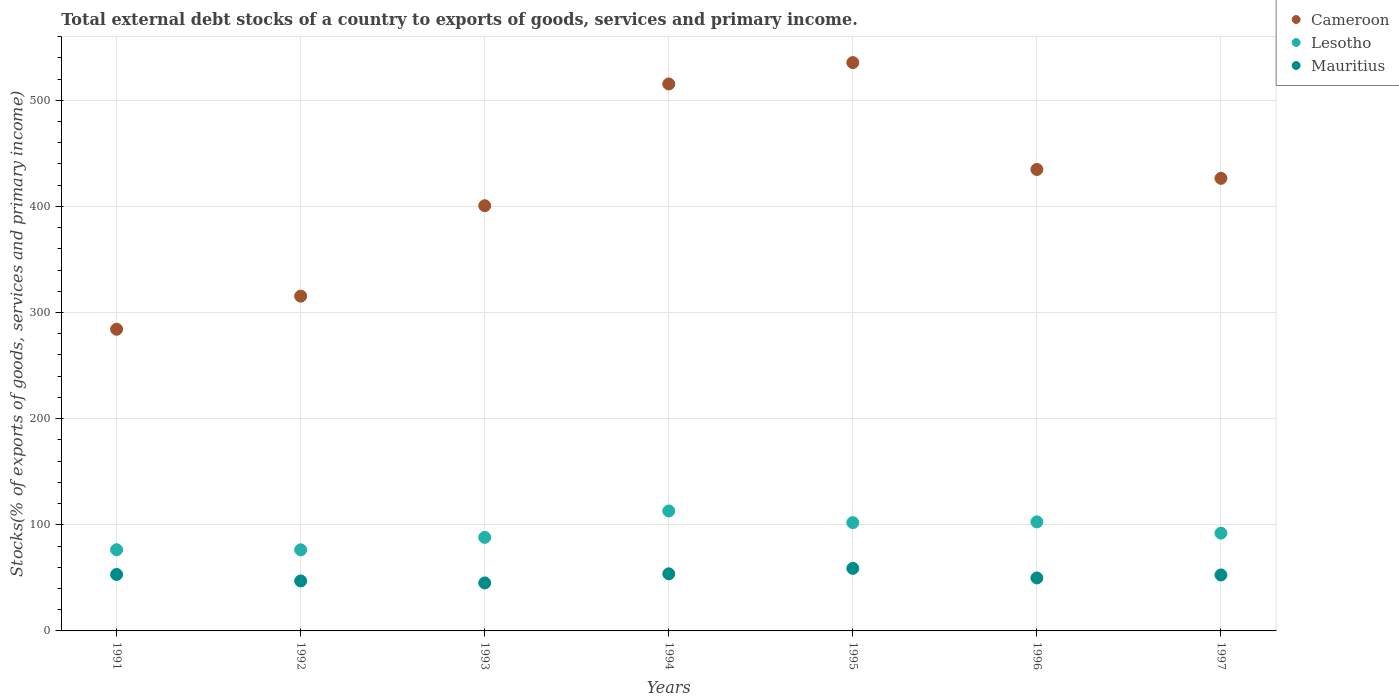How many different coloured dotlines are there?
Your answer should be very brief. 3. What is the total debt stocks in Lesotho in 1997?
Ensure brevity in your answer.  92.13. Across all years, what is the maximum total debt stocks in Cameroon?
Ensure brevity in your answer.  535.53. Across all years, what is the minimum total debt stocks in Lesotho?
Keep it short and to the point. 76.44. What is the total total debt stocks in Cameroon in the graph?
Your answer should be very brief. 2912.61. What is the difference between the total debt stocks in Lesotho in 1992 and that in 1995?
Offer a terse response. -25.62. What is the difference between the total debt stocks in Mauritius in 1991 and the total debt stocks in Lesotho in 1992?
Your answer should be compact. -23.24. What is the average total debt stocks in Cameroon per year?
Your response must be concise. 416.09. In the year 1992, what is the difference between the total debt stocks in Lesotho and total debt stocks in Mauritius?
Your answer should be very brief. 29.33. What is the ratio of the total debt stocks in Mauritius in 1991 to that in 1995?
Give a very brief answer. 0.9. What is the difference between the highest and the second highest total debt stocks in Lesotho?
Your answer should be compact. 10.27. What is the difference between the highest and the lowest total debt stocks in Cameroon?
Give a very brief answer. 251.26. In how many years, is the total debt stocks in Cameroon greater than the average total debt stocks in Cameroon taken over all years?
Keep it short and to the point. 4. Is the sum of the total debt stocks in Lesotho in 1992 and 1997 greater than the maximum total debt stocks in Mauritius across all years?
Keep it short and to the point. Yes. Is the total debt stocks in Cameroon strictly greater than the total debt stocks in Lesotho over the years?
Ensure brevity in your answer.  Yes. How many years are there in the graph?
Make the answer very short. 7. Does the graph contain any zero values?
Offer a terse response. No. Where does the legend appear in the graph?
Your answer should be compact. Top right. How many legend labels are there?
Your response must be concise. 3. What is the title of the graph?
Provide a short and direct response. Total external debt stocks of a country to exports of goods, services and primary income. Does "Montenegro" appear as one of the legend labels in the graph?
Provide a short and direct response. No. What is the label or title of the Y-axis?
Provide a short and direct response. Stocks(% of exports of goods, services and primary income). What is the Stocks(% of exports of goods, services and primary income) of Cameroon in 1991?
Your response must be concise. 284.26. What is the Stocks(% of exports of goods, services and primary income) of Lesotho in 1991?
Your response must be concise. 76.5. What is the Stocks(% of exports of goods, services and primary income) in Mauritius in 1991?
Provide a succinct answer. 53.2. What is the Stocks(% of exports of goods, services and primary income) of Cameroon in 1992?
Offer a very short reply. 315.47. What is the Stocks(% of exports of goods, services and primary income) in Lesotho in 1992?
Offer a terse response. 76.44. What is the Stocks(% of exports of goods, services and primary income) in Mauritius in 1992?
Offer a terse response. 47.11. What is the Stocks(% of exports of goods, services and primary income) of Cameroon in 1993?
Provide a succinct answer. 400.67. What is the Stocks(% of exports of goods, services and primary income) of Lesotho in 1993?
Your answer should be compact. 88.13. What is the Stocks(% of exports of goods, services and primary income) in Mauritius in 1993?
Offer a terse response. 45.22. What is the Stocks(% of exports of goods, services and primary income) of Cameroon in 1994?
Provide a succinct answer. 515.38. What is the Stocks(% of exports of goods, services and primary income) in Lesotho in 1994?
Offer a very short reply. 113.02. What is the Stocks(% of exports of goods, services and primary income) of Mauritius in 1994?
Your answer should be very brief. 53.81. What is the Stocks(% of exports of goods, services and primary income) in Cameroon in 1995?
Provide a short and direct response. 535.53. What is the Stocks(% of exports of goods, services and primary income) in Lesotho in 1995?
Your response must be concise. 102.05. What is the Stocks(% of exports of goods, services and primary income) of Mauritius in 1995?
Your answer should be very brief. 58.92. What is the Stocks(% of exports of goods, services and primary income) of Cameroon in 1996?
Keep it short and to the point. 434.84. What is the Stocks(% of exports of goods, services and primary income) of Lesotho in 1996?
Your answer should be compact. 102.75. What is the Stocks(% of exports of goods, services and primary income) of Mauritius in 1996?
Keep it short and to the point. 49.92. What is the Stocks(% of exports of goods, services and primary income) in Cameroon in 1997?
Provide a succinct answer. 426.46. What is the Stocks(% of exports of goods, services and primary income) in Lesotho in 1997?
Your answer should be very brief. 92.13. What is the Stocks(% of exports of goods, services and primary income) of Mauritius in 1997?
Offer a terse response. 52.73. Across all years, what is the maximum Stocks(% of exports of goods, services and primary income) in Cameroon?
Provide a short and direct response. 535.53. Across all years, what is the maximum Stocks(% of exports of goods, services and primary income) of Lesotho?
Your response must be concise. 113.02. Across all years, what is the maximum Stocks(% of exports of goods, services and primary income) of Mauritius?
Keep it short and to the point. 58.92. Across all years, what is the minimum Stocks(% of exports of goods, services and primary income) in Cameroon?
Your answer should be compact. 284.26. Across all years, what is the minimum Stocks(% of exports of goods, services and primary income) of Lesotho?
Give a very brief answer. 76.44. Across all years, what is the minimum Stocks(% of exports of goods, services and primary income) of Mauritius?
Ensure brevity in your answer.  45.22. What is the total Stocks(% of exports of goods, services and primary income) in Cameroon in the graph?
Offer a terse response. 2912.61. What is the total Stocks(% of exports of goods, services and primary income) in Lesotho in the graph?
Your answer should be very brief. 651.03. What is the total Stocks(% of exports of goods, services and primary income) of Mauritius in the graph?
Provide a short and direct response. 360.91. What is the difference between the Stocks(% of exports of goods, services and primary income) in Cameroon in 1991 and that in 1992?
Provide a short and direct response. -31.2. What is the difference between the Stocks(% of exports of goods, services and primary income) in Lesotho in 1991 and that in 1992?
Keep it short and to the point. 0.06. What is the difference between the Stocks(% of exports of goods, services and primary income) in Mauritius in 1991 and that in 1992?
Offer a terse response. 6.09. What is the difference between the Stocks(% of exports of goods, services and primary income) in Cameroon in 1991 and that in 1993?
Keep it short and to the point. -116.4. What is the difference between the Stocks(% of exports of goods, services and primary income) in Lesotho in 1991 and that in 1993?
Make the answer very short. -11.63. What is the difference between the Stocks(% of exports of goods, services and primary income) in Mauritius in 1991 and that in 1993?
Provide a succinct answer. 7.98. What is the difference between the Stocks(% of exports of goods, services and primary income) of Cameroon in 1991 and that in 1994?
Your response must be concise. -231.12. What is the difference between the Stocks(% of exports of goods, services and primary income) in Lesotho in 1991 and that in 1994?
Your answer should be very brief. -36.52. What is the difference between the Stocks(% of exports of goods, services and primary income) of Mauritius in 1991 and that in 1994?
Keep it short and to the point. -0.61. What is the difference between the Stocks(% of exports of goods, services and primary income) of Cameroon in 1991 and that in 1995?
Your answer should be compact. -251.26. What is the difference between the Stocks(% of exports of goods, services and primary income) in Lesotho in 1991 and that in 1995?
Keep it short and to the point. -25.55. What is the difference between the Stocks(% of exports of goods, services and primary income) in Mauritius in 1991 and that in 1995?
Give a very brief answer. -5.72. What is the difference between the Stocks(% of exports of goods, services and primary income) of Cameroon in 1991 and that in 1996?
Provide a short and direct response. -150.57. What is the difference between the Stocks(% of exports of goods, services and primary income) in Lesotho in 1991 and that in 1996?
Your response must be concise. -26.25. What is the difference between the Stocks(% of exports of goods, services and primary income) of Mauritius in 1991 and that in 1996?
Your answer should be compact. 3.28. What is the difference between the Stocks(% of exports of goods, services and primary income) of Cameroon in 1991 and that in 1997?
Provide a succinct answer. -142.2. What is the difference between the Stocks(% of exports of goods, services and primary income) in Lesotho in 1991 and that in 1997?
Provide a succinct answer. -15.63. What is the difference between the Stocks(% of exports of goods, services and primary income) of Mauritius in 1991 and that in 1997?
Make the answer very short. 0.47. What is the difference between the Stocks(% of exports of goods, services and primary income) of Cameroon in 1992 and that in 1993?
Your response must be concise. -85.2. What is the difference between the Stocks(% of exports of goods, services and primary income) in Lesotho in 1992 and that in 1993?
Provide a succinct answer. -11.69. What is the difference between the Stocks(% of exports of goods, services and primary income) of Mauritius in 1992 and that in 1993?
Your answer should be compact. 1.89. What is the difference between the Stocks(% of exports of goods, services and primary income) of Cameroon in 1992 and that in 1994?
Ensure brevity in your answer.  -199.91. What is the difference between the Stocks(% of exports of goods, services and primary income) of Lesotho in 1992 and that in 1994?
Provide a succinct answer. -36.59. What is the difference between the Stocks(% of exports of goods, services and primary income) of Mauritius in 1992 and that in 1994?
Your answer should be compact. -6.7. What is the difference between the Stocks(% of exports of goods, services and primary income) of Cameroon in 1992 and that in 1995?
Provide a succinct answer. -220.06. What is the difference between the Stocks(% of exports of goods, services and primary income) of Lesotho in 1992 and that in 1995?
Provide a succinct answer. -25.62. What is the difference between the Stocks(% of exports of goods, services and primary income) of Mauritius in 1992 and that in 1995?
Offer a terse response. -11.81. What is the difference between the Stocks(% of exports of goods, services and primary income) of Cameroon in 1992 and that in 1996?
Your response must be concise. -119.37. What is the difference between the Stocks(% of exports of goods, services and primary income) in Lesotho in 1992 and that in 1996?
Provide a short and direct response. -26.31. What is the difference between the Stocks(% of exports of goods, services and primary income) of Mauritius in 1992 and that in 1996?
Ensure brevity in your answer.  -2.81. What is the difference between the Stocks(% of exports of goods, services and primary income) in Cameroon in 1992 and that in 1997?
Offer a terse response. -111. What is the difference between the Stocks(% of exports of goods, services and primary income) in Lesotho in 1992 and that in 1997?
Offer a terse response. -15.7. What is the difference between the Stocks(% of exports of goods, services and primary income) of Mauritius in 1992 and that in 1997?
Provide a short and direct response. -5.62. What is the difference between the Stocks(% of exports of goods, services and primary income) in Cameroon in 1993 and that in 1994?
Keep it short and to the point. -114.71. What is the difference between the Stocks(% of exports of goods, services and primary income) in Lesotho in 1993 and that in 1994?
Give a very brief answer. -24.9. What is the difference between the Stocks(% of exports of goods, services and primary income) of Mauritius in 1993 and that in 1994?
Your response must be concise. -8.59. What is the difference between the Stocks(% of exports of goods, services and primary income) of Cameroon in 1993 and that in 1995?
Ensure brevity in your answer.  -134.86. What is the difference between the Stocks(% of exports of goods, services and primary income) of Lesotho in 1993 and that in 1995?
Your answer should be compact. -13.93. What is the difference between the Stocks(% of exports of goods, services and primary income) in Mauritius in 1993 and that in 1995?
Offer a very short reply. -13.7. What is the difference between the Stocks(% of exports of goods, services and primary income) in Cameroon in 1993 and that in 1996?
Your answer should be very brief. -34.17. What is the difference between the Stocks(% of exports of goods, services and primary income) in Lesotho in 1993 and that in 1996?
Ensure brevity in your answer.  -14.63. What is the difference between the Stocks(% of exports of goods, services and primary income) of Mauritius in 1993 and that in 1996?
Your answer should be compact. -4.7. What is the difference between the Stocks(% of exports of goods, services and primary income) of Cameroon in 1993 and that in 1997?
Give a very brief answer. -25.79. What is the difference between the Stocks(% of exports of goods, services and primary income) in Lesotho in 1993 and that in 1997?
Offer a terse response. -4.01. What is the difference between the Stocks(% of exports of goods, services and primary income) of Mauritius in 1993 and that in 1997?
Your answer should be compact. -7.51. What is the difference between the Stocks(% of exports of goods, services and primary income) of Cameroon in 1994 and that in 1995?
Ensure brevity in your answer.  -20.15. What is the difference between the Stocks(% of exports of goods, services and primary income) in Lesotho in 1994 and that in 1995?
Your response must be concise. 10.97. What is the difference between the Stocks(% of exports of goods, services and primary income) of Mauritius in 1994 and that in 1995?
Provide a short and direct response. -5.11. What is the difference between the Stocks(% of exports of goods, services and primary income) of Cameroon in 1994 and that in 1996?
Provide a succinct answer. 80.54. What is the difference between the Stocks(% of exports of goods, services and primary income) of Lesotho in 1994 and that in 1996?
Offer a very short reply. 10.27. What is the difference between the Stocks(% of exports of goods, services and primary income) of Mauritius in 1994 and that in 1996?
Make the answer very short. 3.89. What is the difference between the Stocks(% of exports of goods, services and primary income) of Cameroon in 1994 and that in 1997?
Offer a very short reply. 88.92. What is the difference between the Stocks(% of exports of goods, services and primary income) in Lesotho in 1994 and that in 1997?
Your response must be concise. 20.89. What is the difference between the Stocks(% of exports of goods, services and primary income) of Mauritius in 1994 and that in 1997?
Ensure brevity in your answer.  1.09. What is the difference between the Stocks(% of exports of goods, services and primary income) in Cameroon in 1995 and that in 1996?
Your answer should be compact. 100.69. What is the difference between the Stocks(% of exports of goods, services and primary income) of Lesotho in 1995 and that in 1996?
Make the answer very short. -0.7. What is the difference between the Stocks(% of exports of goods, services and primary income) in Mauritius in 1995 and that in 1996?
Your response must be concise. 9. What is the difference between the Stocks(% of exports of goods, services and primary income) of Cameroon in 1995 and that in 1997?
Offer a terse response. 109.06. What is the difference between the Stocks(% of exports of goods, services and primary income) in Lesotho in 1995 and that in 1997?
Give a very brief answer. 9.92. What is the difference between the Stocks(% of exports of goods, services and primary income) in Mauritius in 1995 and that in 1997?
Keep it short and to the point. 6.19. What is the difference between the Stocks(% of exports of goods, services and primary income) in Cameroon in 1996 and that in 1997?
Your response must be concise. 8.37. What is the difference between the Stocks(% of exports of goods, services and primary income) in Lesotho in 1996 and that in 1997?
Offer a terse response. 10.62. What is the difference between the Stocks(% of exports of goods, services and primary income) in Mauritius in 1996 and that in 1997?
Your answer should be compact. -2.81. What is the difference between the Stocks(% of exports of goods, services and primary income) of Cameroon in 1991 and the Stocks(% of exports of goods, services and primary income) of Lesotho in 1992?
Provide a short and direct response. 207.83. What is the difference between the Stocks(% of exports of goods, services and primary income) of Cameroon in 1991 and the Stocks(% of exports of goods, services and primary income) of Mauritius in 1992?
Your answer should be compact. 237.15. What is the difference between the Stocks(% of exports of goods, services and primary income) of Lesotho in 1991 and the Stocks(% of exports of goods, services and primary income) of Mauritius in 1992?
Provide a succinct answer. 29.39. What is the difference between the Stocks(% of exports of goods, services and primary income) of Cameroon in 1991 and the Stocks(% of exports of goods, services and primary income) of Lesotho in 1993?
Provide a succinct answer. 196.14. What is the difference between the Stocks(% of exports of goods, services and primary income) in Cameroon in 1991 and the Stocks(% of exports of goods, services and primary income) in Mauritius in 1993?
Your answer should be very brief. 239.04. What is the difference between the Stocks(% of exports of goods, services and primary income) of Lesotho in 1991 and the Stocks(% of exports of goods, services and primary income) of Mauritius in 1993?
Offer a terse response. 31.28. What is the difference between the Stocks(% of exports of goods, services and primary income) of Cameroon in 1991 and the Stocks(% of exports of goods, services and primary income) of Lesotho in 1994?
Offer a terse response. 171.24. What is the difference between the Stocks(% of exports of goods, services and primary income) in Cameroon in 1991 and the Stocks(% of exports of goods, services and primary income) in Mauritius in 1994?
Offer a very short reply. 230.45. What is the difference between the Stocks(% of exports of goods, services and primary income) of Lesotho in 1991 and the Stocks(% of exports of goods, services and primary income) of Mauritius in 1994?
Offer a terse response. 22.69. What is the difference between the Stocks(% of exports of goods, services and primary income) in Cameroon in 1991 and the Stocks(% of exports of goods, services and primary income) in Lesotho in 1995?
Offer a terse response. 182.21. What is the difference between the Stocks(% of exports of goods, services and primary income) in Cameroon in 1991 and the Stocks(% of exports of goods, services and primary income) in Mauritius in 1995?
Your answer should be very brief. 225.34. What is the difference between the Stocks(% of exports of goods, services and primary income) in Lesotho in 1991 and the Stocks(% of exports of goods, services and primary income) in Mauritius in 1995?
Give a very brief answer. 17.58. What is the difference between the Stocks(% of exports of goods, services and primary income) of Cameroon in 1991 and the Stocks(% of exports of goods, services and primary income) of Lesotho in 1996?
Your answer should be very brief. 181.51. What is the difference between the Stocks(% of exports of goods, services and primary income) in Cameroon in 1991 and the Stocks(% of exports of goods, services and primary income) in Mauritius in 1996?
Provide a succinct answer. 234.34. What is the difference between the Stocks(% of exports of goods, services and primary income) in Lesotho in 1991 and the Stocks(% of exports of goods, services and primary income) in Mauritius in 1996?
Your answer should be compact. 26.58. What is the difference between the Stocks(% of exports of goods, services and primary income) in Cameroon in 1991 and the Stocks(% of exports of goods, services and primary income) in Lesotho in 1997?
Ensure brevity in your answer.  192.13. What is the difference between the Stocks(% of exports of goods, services and primary income) in Cameroon in 1991 and the Stocks(% of exports of goods, services and primary income) in Mauritius in 1997?
Your answer should be very brief. 231.54. What is the difference between the Stocks(% of exports of goods, services and primary income) in Lesotho in 1991 and the Stocks(% of exports of goods, services and primary income) in Mauritius in 1997?
Offer a terse response. 23.77. What is the difference between the Stocks(% of exports of goods, services and primary income) in Cameroon in 1992 and the Stocks(% of exports of goods, services and primary income) in Lesotho in 1993?
Offer a terse response. 227.34. What is the difference between the Stocks(% of exports of goods, services and primary income) in Cameroon in 1992 and the Stocks(% of exports of goods, services and primary income) in Mauritius in 1993?
Your response must be concise. 270.25. What is the difference between the Stocks(% of exports of goods, services and primary income) of Lesotho in 1992 and the Stocks(% of exports of goods, services and primary income) of Mauritius in 1993?
Make the answer very short. 31.22. What is the difference between the Stocks(% of exports of goods, services and primary income) of Cameroon in 1992 and the Stocks(% of exports of goods, services and primary income) of Lesotho in 1994?
Make the answer very short. 202.44. What is the difference between the Stocks(% of exports of goods, services and primary income) in Cameroon in 1992 and the Stocks(% of exports of goods, services and primary income) in Mauritius in 1994?
Your answer should be compact. 261.65. What is the difference between the Stocks(% of exports of goods, services and primary income) in Lesotho in 1992 and the Stocks(% of exports of goods, services and primary income) in Mauritius in 1994?
Keep it short and to the point. 22.62. What is the difference between the Stocks(% of exports of goods, services and primary income) in Cameroon in 1992 and the Stocks(% of exports of goods, services and primary income) in Lesotho in 1995?
Ensure brevity in your answer.  213.41. What is the difference between the Stocks(% of exports of goods, services and primary income) of Cameroon in 1992 and the Stocks(% of exports of goods, services and primary income) of Mauritius in 1995?
Your answer should be very brief. 256.55. What is the difference between the Stocks(% of exports of goods, services and primary income) in Lesotho in 1992 and the Stocks(% of exports of goods, services and primary income) in Mauritius in 1995?
Your response must be concise. 17.52. What is the difference between the Stocks(% of exports of goods, services and primary income) in Cameroon in 1992 and the Stocks(% of exports of goods, services and primary income) in Lesotho in 1996?
Your response must be concise. 212.72. What is the difference between the Stocks(% of exports of goods, services and primary income) in Cameroon in 1992 and the Stocks(% of exports of goods, services and primary income) in Mauritius in 1996?
Provide a short and direct response. 265.55. What is the difference between the Stocks(% of exports of goods, services and primary income) of Lesotho in 1992 and the Stocks(% of exports of goods, services and primary income) of Mauritius in 1996?
Keep it short and to the point. 26.52. What is the difference between the Stocks(% of exports of goods, services and primary income) in Cameroon in 1992 and the Stocks(% of exports of goods, services and primary income) in Lesotho in 1997?
Offer a terse response. 223.33. What is the difference between the Stocks(% of exports of goods, services and primary income) in Cameroon in 1992 and the Stocks(% of exports of goods, services and primary income) in Mauritius in 1997?
Make the answer very short. 262.74. What is the difference between the Stocks(% of exports of goods, services and primary income) in Lesotho in 1992 and the Stocks(% of exports of goods, services and primary income) in Mauritius in 1997?
Your answer should be very brief. 23.71. What is the difference between the Stocks(% of exports of goods, services and primary income) of Cameroon in 1993 and the Stocks(% of exports of goods, services and primary income) of Lesotho in 1994?
Keep it short and to the point. 287.64. What is the difference between the Stocks(% of exports of goods, services and primary income) of Cameroon in 1993 and the Stocks(% of exports of goods, services and primary income) of Mauritius in 1994?
Your answer should be compact. 346.86. What is the difference between the Stocks(% of exports of goods, services and primary income) in Lesotho in 1993 and the Stocks(% of exports of goods, services and primary income) in Mauritius in 1994?
Your answer should be compact. 34.31. What is the difference between the Stocks(% of exports of goods, services and primary income) in Cameroon in 1993 and the Stocks(% of exports of goods, services and primary income) in Lesotho in 1995?
Your response must be concise. 298.62. What is the difference between the Stocks(% of exports of goods, services and primary income) of Cameroon in 1993 and the Stocks(% of exports of goods, services and primary income) of Mauritius in 1995?
Your response must be concise. 341.75. What is the difference between the Stocks(% of exports of goods, services and primary income) in Lesotho in 1993 and the Stocks(% of exports of goods, services and primary income) in Mauritius in 1995?
Your answer should be compact. 29.2. What is the difference between the Stocks(% of exports of goods, services and primary income) in Cameroon in 1993 and the Stocks(% of exports of goods, services and primary income) in Lesotho in 1996?
Your answer should be very brief. 297.92. What is the difference between the Stocks(% of exports of goods, services and primary income) of Cameroon in 1993 and the Stocks(% of exports of goods, services and primary income) of Mauritius in 1996?
Provide a short and direct response. 350.75. What is the difference between the Stocks(% of exports of goods, services and primary income) of Lesotho in 1993 and the Stocks(% of exports of goods, services and primary income) of Mauritius in 1996?
Your answer should be compact. 38.21. What is the difference between the Stocks(% of exports of goods, services and primary income) in Cameroon in 1993 and the Stocks(% of exports of goods, services and primary income) in Lesotho in 1997?
Ensure brevity in your answer.  308.53. What is the difference between the Stocks(% of exports of goods, services and primary income) of Cameroon in 1993 and the Stocks(% of exports of goods, services and primary income) of Mauritius in 1997?
Keep it short and to the point. 347.94. What is the difference between the Stocks(% of exports of goods, services and primary income) of Lesotho in 1993 and the Stocks(% of exports of goods, services and primary income) of Mauritius in 1997?
Ensure brevity in your answer.  35.4. What is the difference between the Stocks(% of exports of goods, services and primary income) of Cameroon in 1994 and the Stocks(% of exports of goods, services and primary income) of Lesotho in 1995?
Offer a terse response. 413.33. What is the difference between the Stocks(% of exports of goods, services and primary income) in Cameroon in 1994 and the Stocks(% of exports of goods, services and primary income) in Mauritius in 1995?
Give a very brief answer. 456.46. What is the difference between the Stocks(% of exports of goods, services and primary income) in Lesotho in 1994 and the Stocks(% of exports of goods, services and primary income) in Mauritius in 1995?
Keep it short and to the point. 54.1. What is the difference between the Stocks(% of exports of goods, services and primary income) of Cameroon in 1994 and the Stocks(% of exports of goods, services and primary income) of Lesotho in 1996?
Your response must be concise. 412.63. What is the difference between the Stocks(% of exports of goods, services and primary income) in Cameroon in 1994 and the Stocks(% of exports of goods, services and primary income) in Mauritius in 1996?
Offer a very short reply. 465.46. What is the difference between the Stocks(% of exports of goods, services and primary income) of Lesotho in 1994 and the Stocks(% of exports of goods, services and primary income) of Mauritius in 1996?
Your answer should be compact. 63.1. What is the difference between the Stocks(% of exports of goods, services and primary income) of Cameroon in 1994 and the Stocks(% of exports of goods, services and primary income) of Lesotho in 1997?
Make the answer very short. 423.25. What is the difference between the Stocks(% of exports of goods, services and primary income) in Cameroon in 1994 and the Stocks(% of exports of goods, services and primary income) in Mauritius in 1997?
Offer a terse response. 462.65. What is the difference between the Stocks(% of exports of goods, services and primary income) of Lesotho in 1994 and the Stocks(% of exports of goods, services and primary income) of Mauritius in 1997?
Offer a very short reply. 60.3. What is the difference between the Stocks(% of exports of goods, services and primary income) in Cameroon in 1995 and the Stocks(% of exports of goods, services and primary income) in Lesotho in 1996?
Keep it short and to the point. 432.77. What is the difference between the Stocks(% of exports of goods, services and primary income) in Cameroon in 1995 and the Stocks(% of exports of goods, services and primary income) in Mauritius in 1996?
Ensure brevity in your answer.  485.61. What is the difference between the Stocks(% of exports of goods, services and primary income) of Lesotho in 1995 and the Stocks(% of exports of goods, services and primary income) of Mauritius in 1996?
Ensure brevity in your answer.  52.13. What is the difference between the Stocks(% of exports of goods, services and primary income) in Cameroon in 1995 and the Stocks(% of exports of goods, services and primary income) in Lesotho in 1997?
Give a very brief answer. 443.39. What is the difference between the Stocks(% of exports of goods, services and primary income) of Cameroon in 1995 and the Stocks(% of exports of goods, services and primary income) of Mauritius in 1997?
Ensure brevity in your answer.  482.8. What is the difference between the Stocks(% of exports of goods, services and primary income) in Lesotho in 1995 and the Stocks(% of exports of goods, services and primary income) in Mauritius in 1997?
Make the answer very short. 49.33. What is the difference between the Stocks(% of exports of goods, services and primary income) in Cameroon in 1996 and the Stocks(% of exports of goods, services and primary income) in Lesotho in 1997?
Make the answer very short. 342.7. What is the difference between the Stocks(% of exports of goods, services and primary income) of Cameroon in 1996 and the Stocks(% of exports of goods, services and primary income) of Mauritius in 1997?
Your answer should be very brief. 382.11. What is the difference between the Stocks(% of exports of goods, services and primary income) in Lesotho in 1996 and the Stocks(% of exports of goods, services and primary income) in Mauritius in 1997?
Your response must be concise. 50.02. What is the average Stocks(% of exports of goods, services and primary income) in Cameroon per year?
Ensure brevity in your answer.  416.09. What is the average Stocks(% of exports of goods, services and primary income) of Lesotho per year?
Your response must be concise. 93. What is the average Stocks(% of exports of goods, services and primary income) of Mauritius per year?
Keep it short and to the point. 51.56. In the year 1991, what is the difference between the Stocks(% of exports of goods, services and primary income) of Cameroon and Stocks(% of exports of goods, services and primary income) of Lesotho?
Your answer should be very brief. 207.76. In the year 1991, what is the difference between the Stocks(% of exports of goods, services and primary income) in Cameroon and Stocks(% of exports of goods, services and primary income) in Mauritius?
Offer a terse response. 231.06. In the year 1991, what is the difference between the Stocks(% of exports of goods, services and primary income) in Lesotho and Stocks(% of exports of goods, services and primary income) in Mauritius?
Provide a short and direct response. 23.3. In the year 1992, what is the difference between the Stocks(% of exports of goods, services and primary income) in Cameroon and Stocks(% of exports of goods, services and primary income) in Lesotho?
Your response must be concise. 239.03. In the year 1992, what is the difference between the Stocks(% of exports of goods, services and primary income) of Cameroon and Stocks(% of exports of goods, services and primary income) of Mauritius?
Your response must be concise. 268.36. In the year 1992, what is the difference between the Stocks(% of exports of goods, services and primary income) of Lesotho and Stocks(% of exports of goods, services and primary income) of Mauritius?
Ensure brevity in your answer.  29.33. In the year 1993, what is the difference between the Stocks(% of exports of goods, services and primary income) in Cameroon and Stocks(% of exports of goods, services and primary income) in Lesotho?
Provide a short and direct response. 312.54. In the year 1993, what is the difference between the Stocks(% of exports of goods, services and primary income) of Cameroon and Stocks(% of exports of goods, services and primary income) of Mauritius?
Make the answer very short. 355.45. In the year 1993, what is the difference between the Stocks(% of exports of goods, services and primary income) of Lesotho and Stocks(% of exports of goods, services and primary income) of Mauritius?
Make the answer very short. 42.91. In the year 1994, what is the difference between the Stocks(% of exports of goods, services and primary income) in Cameroon and Stocks(% of exports of goods, services and primary income) in Lesotho?
Offer a very short reply. 402.36. In the year 1994, what is the difference between the Stocks(% of exports of goods, services and primary income) of Cameroon and Stocks(% of exports of goods, services and primary income) of Mauritius?
Provide a short and direct response. 461.57. In the year 1994, what is the difference between the Stocks(% of exports of goods, services and primary income) of Lesotho and Stocks(% of exports of goods, services and primary income) of Mauritius?
Your response must be concise. 59.21. In the year 1995, what is the difference between the Stocks(% of exports of goods, services and primary income) of Cameroon and Stocks(% of exports of goods, services and primary income) of Lesotho?
Your answer should be compact. 433.47. In the year 1995, what is the difference between the Stocks(% of exports of goods, services and primary income) of Cameroon and Stocks(% of exports of goods, services and primary income) of Mauritius?
Your response must be concise. 476.6. In the year 1995, what is the difference between the Stocks(% of exports of goods, services and primary income) of Lesotho and Stocks(% of exports of goods, services and primary income) of Mauritius?
Give a very brief answer. 43.13. In the year 1996, what is the difference between the Stocks(% of exports of goods, services and primary income) in Cameroon and Stocks(% of exports of goods, services and primary income) in Lesotho?
Offer a terse response. 332.09. In the year 1996, what is the difference between the Stocks(% of exports of goods, services and primary income) in Cameroon and Stocks(% of exports of goods, services and primary income) in Mauritius?
Your answer should be very brief. 384.92. In the year 1996, what is the difference between the Stocks(% of exports of goods, services and primary income) in Lesotho and Stocks(% of exports of goods, services and primary income) in Mauritius?
Offer a terse response. 52.83. In the year 1997, what is the difference between the Stocks(% of exports of goods, services and primary income) of Cameroon and Stocks(% of exports of goods, services and primary income) of Lesotho?
Your answer should be very brief. 334.33. In the year 1997, what is the difference between the Stocks(% of exports of goods, services and primary income) of Cameroon and Stocks(% of exports of goods, services and primary income) of Mauritius?
Provide a succinct answer. 373.74. In the year 1997, what is the difference between the Stocks(% of exports of goods, services and primary income) in Lesotho and Stocks(% of exports of goods, services and primary income) in Mauritius?
Your response must be concise. 39.41. What is the ratio of the Stocks(% of exports of goods, services and primary income) of Cameroon in 1991 to that in 1992?
Your answer should be compact. 0.9. What is the ratio of the Stocks(% of exports of goods, services and primary income) in Mauritius in 1991 to that in 1992?
Offer a very short reply. 1.13. What is the ratio of the Stocks(% of exports of goods, services and primary income) of Cameroon in 1991 to that in 1993?
Offer a very short reply. 0.71. What is the ratio of the Stocks(% of exports of goods, services and primary income) of Lesotho in 1991 to that in 1993?
Provide a succinct answer. 0.87. What is the ratio of the Stocks(% of exports of goods, services and primary income) of Mauritius in 1991 to that in 1993?
Offer a very short reply. 1.18. What is the ratio of the Stocks(% of exports of goods, services and primary income) in Cameroon in 1991 to that in 1994?
Keep it short and to the point. 0.55. What is the ratio of the Stocks(% of exports of goods, services and primary income) in Lesotho in 1991 to that in 1994?
Offer a very short reply. 0.68. What is the ratio of the Stocks(% of exports of goods, services and primary income) in Cameroon in 1991 to that in 1995?
Offer a terse response. 0.53. What is the ratio of the Stocks(% of exports of goods, services and primary income) in Lesotho in 1991 to that in 1995?
Offer a very short reply. 0.75. What is the ratio of the Stocks(% of exports of goods, services and primary income) of Mauritius in 1991 to that in 1995?
Make the answer very short. 0.9. What is the ratio of the Stocks(% of exports of goods, services and primary income) of Cameroon in 1991 to that in 1996?
Offer a terse response. 0.65. What is the ratio of the Stocks(% of exports of goods, services and primary income) of Lesotho in 1991 to that in 1996?
Your response must be concise. 0.74. What is the ratio of the Stocks(% of exports of goods, services and primary income) in Mauritius in 1991 to that in 1996?
Ensure brevity in your answer.  1.07. What is the ratio of the Stocks(% of exports of goods, services and primary income) of Cameroon in 1991 to that in 1997?
Give a very brief answer. 0.67. What is the ratio of the Stocks(% of exports of goods, services and primary income) in Lesotho in 1991 to that in 1997?
Provide a short and direct response. 0.83. What is the ratio of the Stocks(% of exports of goods, services and primary income) of Mauritius in 1991 to that in 1997?
Keep it short and to the point. 1.01. What is the ratio of the Stocks(% of exports of goods, services and primary income) of Cameroon in 1992 to that in 1993?
Keep it short and to the point. 0.79. What is the ratio of the Stocks(% of exports of goods, services and primary income) of Lesotho in 1992 to that in 1993?
Give a very brief answer. 0.87. What is the ratio of the Stocks(% of exports of goods, services and primary income) in Mauritius in 1992 to that in 1993?
Ensure brevity in your answer.  1.04. What is the ratio of the Stocks(% of exports of goods, services and primary income) in Cameroon in 1992 to that in 1994?
Give a very brief answer. 0.61. What is the ratio of the Stocks(% of exports of goods, services and primary income) in Lesotho in 1992 to that in 1994?
Your answer should be compact. 0.68. What is the ratio of the Stocks(% of exports of goods, services and primary income) in Mauritius in 1992 to that in 1994?
Your answer should be compact. 0.88. What is the ratio of the Stocks(% of exports of goods, services and primary income) of Cameroon in 1992 to that in 1995?
Make the answer very short. 0.59. What is the ratio of the Stocks(% of exports of goods, services and primary income) in Lesotho in 1992 to that in 1995?
Make the answer very short. 0.75. What is the ratio of the Stocks(% of exports of goods, services and primary income) of Mauritius in 1992 to that in 1995?
Ensure brevity in your answer.  0.8. What is the ratio of the Stocks(% of exports of goods, services and primary income) in Cameroon in 1992 to that in 1996?
Ensure brevity in your answer.  0.73. What is the ratio of the Stocks(% of exports of goods, services and primary income) in Lesotho in 1992 to that in 1996?
Offer a terse response. 0.74. What is the ratio of the Stocks(% of exports of goods, services and primary income) in Mauritius in 1992 to that in 1996?
Make the answer very short. 0.94. What is the ratio of the Stocks(% of exports of goods, services and primary income) in Cameroon in 1992 to that in 1997?
Provide a succinct answer. 0.74. What is the ratio of the Stocks(% of exports of goods, services and primary income) in Lesotho in 1992 to that in 1997?
Offer a very short reply. 0.83. What is the ratio of the Stocks(% of exports of goods, services and primary income) in Mauritius in 1992 to that in 1997?
Your response must be concise. 0.89. What is the ratio of the Stocks(% of exports of goods, services and primary income) in Cameroon in 1993 to that in 1994?
Your response must be concise. 0.78. What is the ratio of the Stocks(% of exports of goods, services and primary income) of Lesotho in 1993 to that in 1994?
Offer a terse response. 0.78. What is the ratio of the Stocks(% of exports of goods, services and primary income) of Mauritius in 1993 to that in 1994?
Give a very brief answer. 0.84. What is the ratio of the Stocks(% of exports of goods, services and primary income) of Cameroon in 1993 to that in 1995?
Your answer should be compact. 0.75. What is the ratio of the Stocks(% of exports of goods, services and primary income) of Lesotho in 1993 to that in 1995?
Your answer should be compact. 0.86. What is the ratio of the Stocks(% of exports of goods, services and primary income) in Mauritius in 1993 to that in 1995?
Offer a terse response. 0.77. What is the ratio of the Stocks(% of exports of goods, services and primary income) of Cameroon in 1993 to that in 1996?
Ensure brevity in your answer.  0.92. What is the ratio of the Stocks(% of exports of goods, services and primary income) in Lesotho in 1993 to that in 1996?
Give a very brief answer. 0.86. What is the ratio of the Stocks(% of exports of goods, services and primary income) in Mauritius in 1993 to that in 1996?
Keep it short and to the point. 0.91. What is the ratio of the Stocks(% of exports of goods, services and primary income) of Cameroon in 1993 to that in 1997?
Ensure brevity in your answer.  0.94. What is the ratio of the Stocks(% of exports of goods, services and primary income) in Lesotho in 1993 to that in 1997?
Provide a succinct answer. 0.96. What is the ratio of the Stocks(% of exports of goods, services and primary income) of Mauritius in 1993 to that in 1997?
Your response must be concise. 0.86. What is the ratio of the Stocks(% of exports of goods, services and primary income) of Cameroon in 1994 to that in 1995?
Keep it short and to the point. 0.96. What is the ratio of the Stocks(% of exports of goods, services and primary income) of Lesotho in 1994 to that in 1995?
Offer a very short reply. 1.11. What is the ratio of the Stocks(% of exports of goods, services and primary income) of Mauritius in 1994 to that in 1995?
Your response must be concise. 0.91. What is the ratio of the Stocks(% of exports of goods, services and primary income) of Cameroon in 1994 to that in 1996?
Provide a succinct answer. 1.19. What is the ratio of the Stocks(% of exports of goods, services and primary income) in Lesotho in 1994 to that in 1996?
Give a very brief answer. 1.1. What is the ratio of the Stocks(% of exports of goods, services and primary income) in Mauritius in 1994 to that in 1996?
Give a very brief answer. 1.08. What is the ratio of the Stocks(% of exports of goods, services and primary income) of Cameroon in 1994 to that in 1997?
Offer a very short reply. 1.21. What is the ratio of the Stocks(% of exports of goods, services and primary income) of Lesotho in 1994 to that in 1997?
Your answer should be compact. 1.23. What is the ratio of the Stocks(% of exports of goods, services and primary income) of Mauritius in 1994 to that in 1997?
Offer a terse response. 1.02. What is the ratio of the Stocks(% of exports of goods, services and primary income) of Cameroon in 1995 to that in 1996?
Provide a short and direct response. 1.23. What is the ratio of the Stocks(% of exports of goods, services and primary income) in Lesotho in 1995 to that in 1996?
Keep it short and to the point. 0.99. What is the ratio of the Stocks(% of exports of goods, services and primary income) in Mauritius in 1995 to that in 1996?
Your answer should be compact. 1.18. What is the ratio of the Stocks(% of exports of goods, services and primary income) in Cameroon in 1995 to that in 1997?
Provide a short and direct response. 1.26. What is the ratio of the Stocks(% of exports of goods, services and primary income) in Lesotho in 1995 to that in 1997?
Your response must be concise. 1.11. What is the ratio of the Stocks(% of exports of goods, services and primary income) in Mauritius in 1995 to that in 1997?
Offer a terse response. 1.12. What is the ratio of the Stocks(% of exports of goods, services and primary income) of Cameroon in 1996 to that in 1997?
Your response must be concise. 1.02. What is the ratio of the Stocks(% of exports of goods, services and primary income) in Lesotho in 1996 to that in 1997?
Your answer should be compact. 1.12. What is the ratio of the Stocks(% of exports of goods, services and primary income) in Mauritius in 1996 to that in 1997?
Offer a terse response. 0.95. What is the difference between the highest and the second highest Stocks(% of exports of goods, services and primary income) of Cameroon?
Provide a succinct answer. 20.15. What is the difference between the highest and the second highest Stocks(% of exports of goods, services and primary income) of Lesotho?
Provide a succinct answer. 10.27. What is the difference between the highest and the second highest Stocks(% of exports of goods, services and primary income) of Mauritius?
Your response must be concise. 5.11. What is the difference between the highest and the lowest Stocks(% of exports of goods, services and primary income) of Cameroon?
Your response must be concise. 251.26. What is the difference between the highest and the lowest Stocks(% of exports of goods, services and primary income) in Lesotho?
Provide a short and direct response. 36.59. What is the difference between the highest and the lowest Stocks(% of exports of goods, services and primary income) of Mauritius?
Your answer should be very brief. 13.7. 